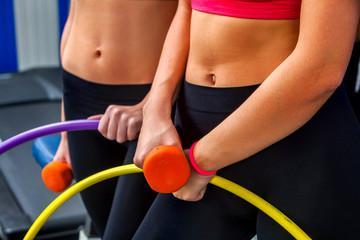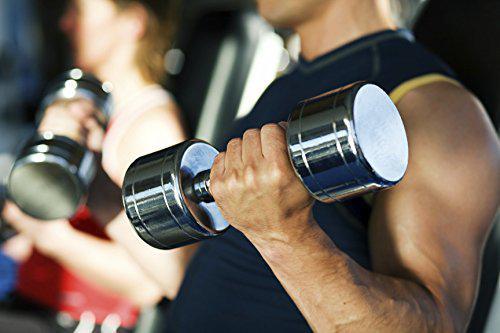The first image is the image on the left, the second image is the image on the right. For the images shown, is this caption "The person in the image on the left is holding one black barbell." true? Answer yes or no. No. 